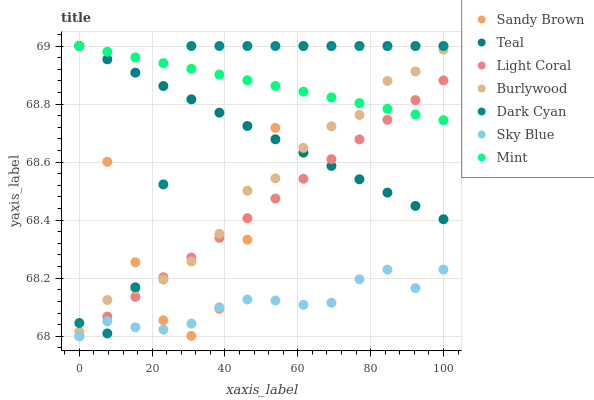Does Sky Blue have the minimum area under the curve?
Answer yes or no. Yes. Does Mint have the maximum area under the curve?
Answer yes or no. Yes. Does Light Coral have the minimum area under the curve?
Answer yes or no. No. Does Light Coral have the maximum area under the curve?
Answer yes or no. No. Is Mint the smoothest?
Answer yes or no. Yes. Is Sandy Brown the roughest?
Answer yes or no. Yes. Is Light Coral the smoothest?
Answer yes or no. No. Is Light Coral the roughest?
Answer yes or no. No. Does Light Coral have the lowest value?
Answer yes or no. Yes. Does Mint have the lowest value?
Answer yes or no. No. Does Sandy Brown have the highest value?
Answer yes or no. Yes. Does Light Coral have the highest value?
Answer yes or no. No. Is Sky Blue less than Mint?
Answer yes or no. Yes. Is Burlywood greater than Sky Blue?
Answer yes or no. Yes. Does Light Coral intersect Mint?
Answer yes or no. Yes. Is Light Coral less than Mint?
Answer yes or no. No. Is Light Coral greater than Mint?
Answer yes or no. No. Does Sky Blue intersect Mint?
Answer yes or no. No. 